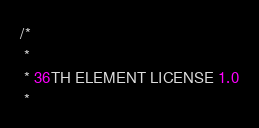Convert code to text. <code><loc_0><loc_0><loc_500><loc_500><_Java_>/*
 * 
 * 36TH ELEMENT LICENSE 1.0
 *</code> 